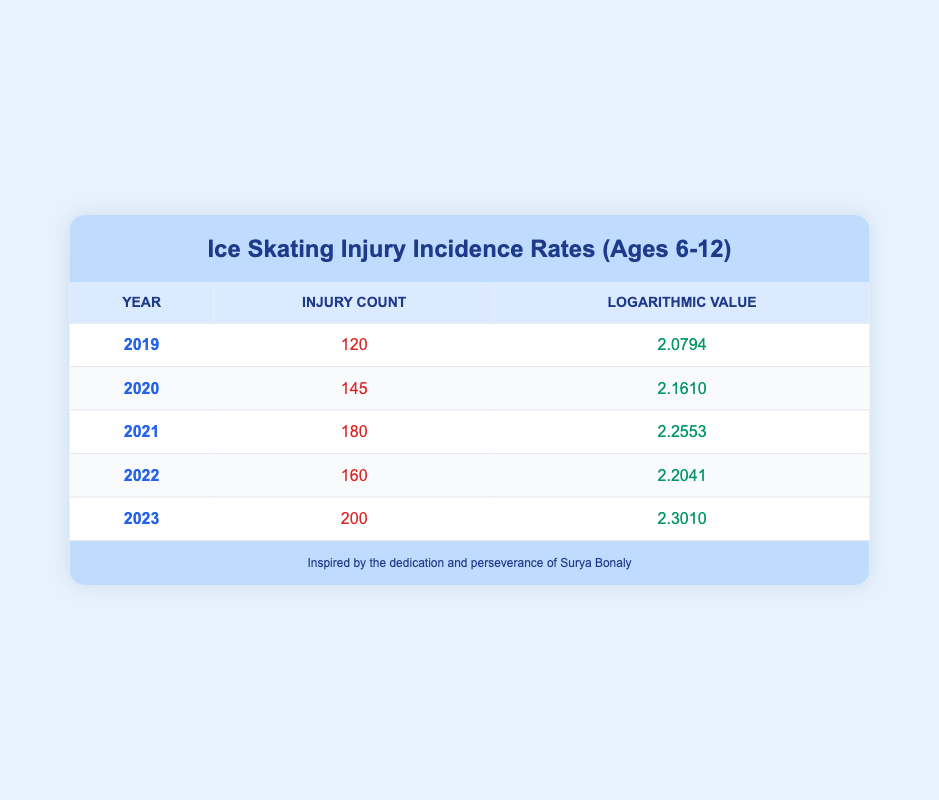What was the injury count in 2020? Referring to the table under the Year 2020, the Injury Count is listed as 145.
Answer: 145 What is the logarithmic value for the year 2023? The table specifically states that the logarithmic value for the year 2023 is 2.3010.
Answer: 2.3010 What is the difference in injury counts between 2021 and 2022? The injury count for 2021 is 180, and for 2022 it is 160. Subtracting these values: 180 - 160 = 20.
Answer: 20 Was there an increase in injury counts from 2021 to 2023? The injury count in 2021 is 180, and in 2023 it is 200. Since 200 is greater than 180, there is an increase.
Answer: Yes What was the average injury count over the five years? To calculate the average, sum the injury counts: 120 + 145 + 180 + 160 + 200 = 805. Then divide by 5 (the number of years): 805 / 5 = 161.
Answer: 161 How many years had an injury count greater than 150? The years with an injury count greater than 150 are 2020 (145), 2021 (180), 2022 (160), and 2023 (200), totaling four years.
Answer: 4 Which year had the highest injury count? By observing the injury counts listed, 2023 with 200 injuries is the highest compared to all other years.
Answer: 2023 What is the logarithmic value for the year with the lowest injury count? The year with the lowest injury count is 2019 with 120 injuries, and its logarithmic value is 2.0794.
Answer: 2.0794 What is the change in logarithmic value from 2019 to 2021? The logarithmic value in 2019 is 2.0794 and in 2021 is 2.2553. The change is calculated as 2.2553 - 2.0794 = 0.1759.
Answer: 0.1759 